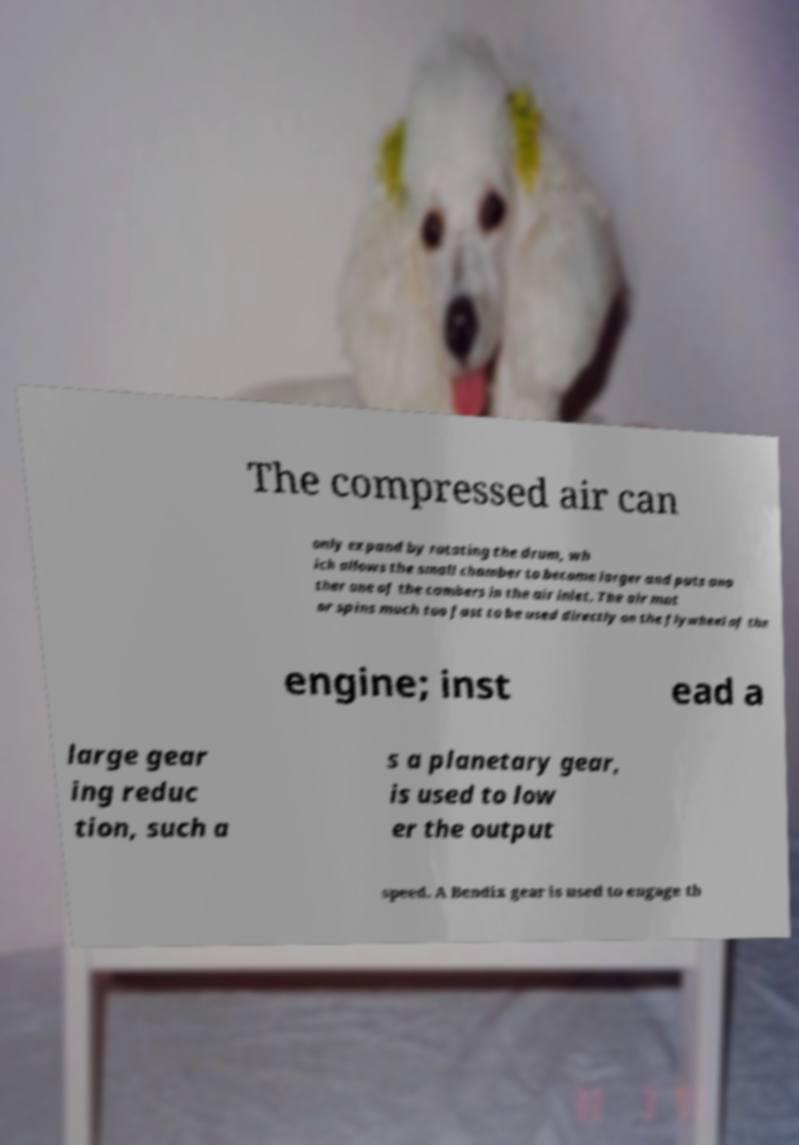Can you read and provide the text displayed in the image?This photo seems to have some interesting text. Can you extract and type it out for me? The compressed air can only expand by rotating the drum, wh ich allows the small chamber to become larger and puts ano ther one of the cambers in the air inlet. The air mot or spins much too fast to be used directly on the flywheel of the engine; inst ead a large gear ing reduc tion, such a s a planetary gear, is used to low er the output speed. A Bendix gear is used to engage th 